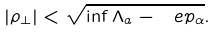Convert formula to latex. <formula><loc_0><loc_0><loc_500><loc_500>| \rho _ { \perp } | < \sqrt { \inf \Lambda _ { a } - \ e p _ { \alpha } } .</formula> 